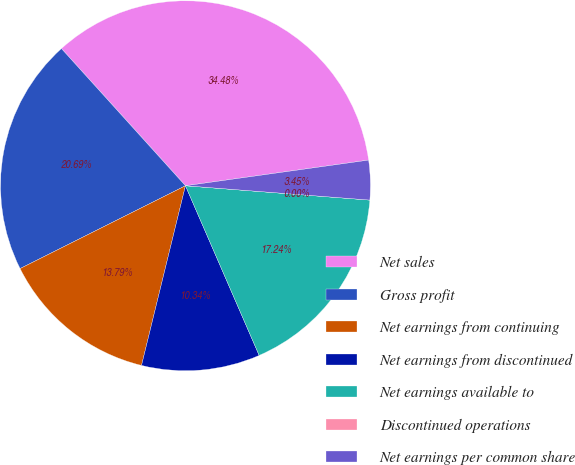Convert chart. <chart><loc_0><loc_0><loc_500><loc_500><pie_chart><fcel>Net sales<fcel>Gross profit<fcel>Net earnings from continuing<fcel>Net earnings from discontinued<fcel>Net earnings available to<fcel>Discontinued operations<fcel>Net earnings per common share<nl><fcel>34.48%<fcel>20.69%<fcel>13.79%<fcel>10.34%<fcel>17.24%<fcel>0.0%<fcel>3.45%<nl></chart> 